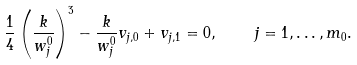Convert formula to latex. <formula><loc_0><loc_0><loc_500><loc_500>\frac { 1 } { 4 } \left ( \frac { k } { w _ { j } ^ { 0 } } \right ) ^ { 3 } - \frac { k } { w _ { j } ^ { 0 } } v _ { j , 0 } + v _ { j , 1 } = 0 , \quad j = 1 , \dots , m _ { 0 } .</formula> 